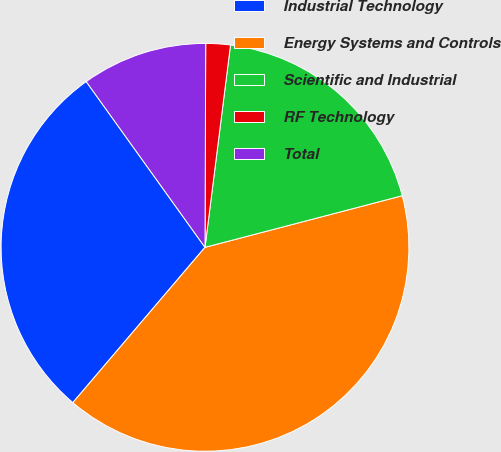Convert chart. <chart><loc_0><loc_0><loc_500><loc_500><pie_chart><fcel>Industrial Technology<fcel>Energy Systems and Controls<fcel>Scientific and Industrial<fcel>RF Technology<fcel>Total<nl><fcel>28.88%<fcel>40.29%<fcel>18.93%<fcel>1.94%<fcel>9.95%<nl></chart> 